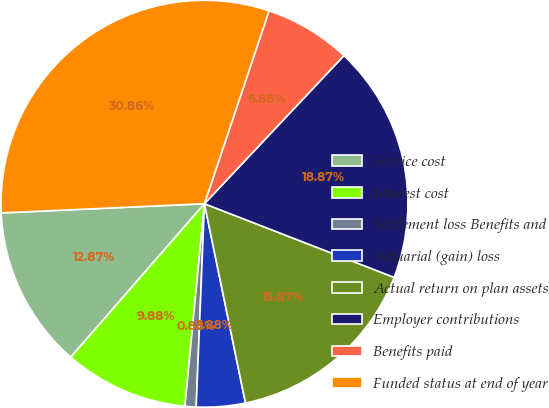Convert chart. <chart><loc_0><loc_0><loc_500><loc_500><pie_chart><fcel>Service cost<fcel>Interest cost<fcel>Settlement loss Benefits and<fcel>Actuarial (gain) loss<fcel>Actual return on plan assets<fcel>Employer contributions<fcel>Benefits paid<fcel>Funded status at end of year<nl><fcel>12.87%<fcel>9.88%<fcel>0.88%<fcel>3.88%<fcel>15.87%<fcel>18.87%<fcel>6.88%<fcel>30.86%<nl></chart> 